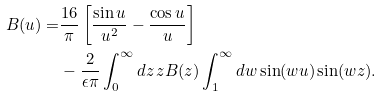Convert formula to latex. <formula><loc_0><loc_0><loc_500><loc_500>B ( u ) = & \frac { 1 6 } { \pi } \left [ \frac { \sin u } { u ^ { 2 } } - \frac { \cos u } { u } \right ] \\ & - \frac { 2 } { \epsilon \pi } \int _ { 0 } ^ { \infty } d z \, z B ( z ) \int _ { 1 } ^ { \infty } d w \sin ( w u ) \sin ( w z ) .</formula> 